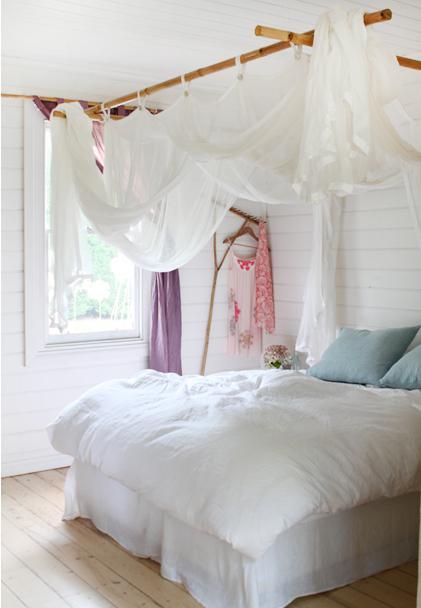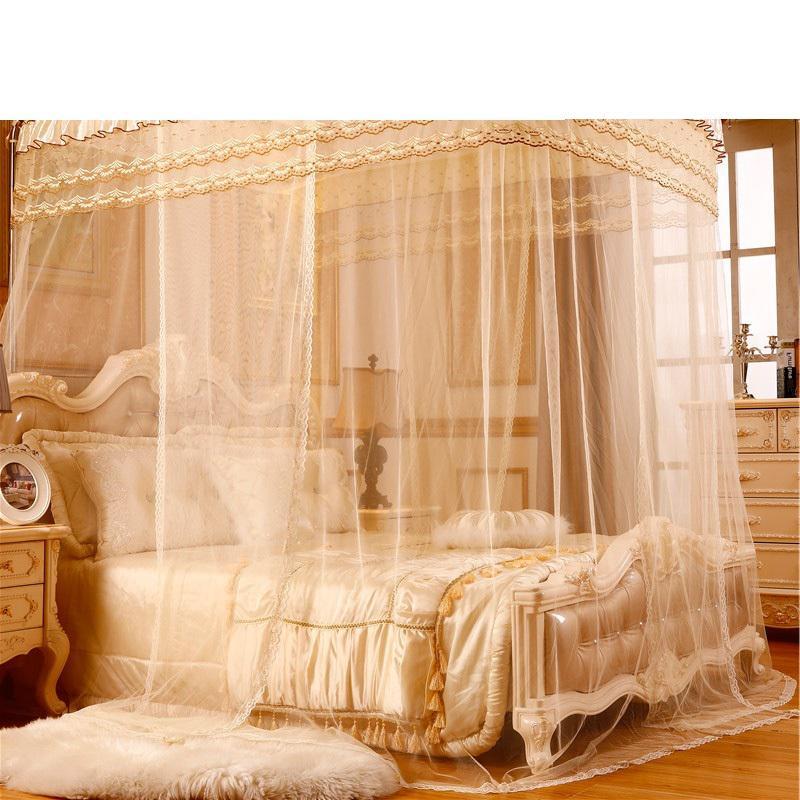The first image is the image on the left, the second image is the image on the right. Considering the images on both sides, is "Drapes cover half of the bed in the left image and a tent like dome covers the whole bed in the right image." valid? Answer yes or no. No. The first image is the image on the left, the second image is the image on the right. Considering the images on both sides, is "There is a rounded net sitting over the bed in the image on the right." valid? Answer yes or no. No. 